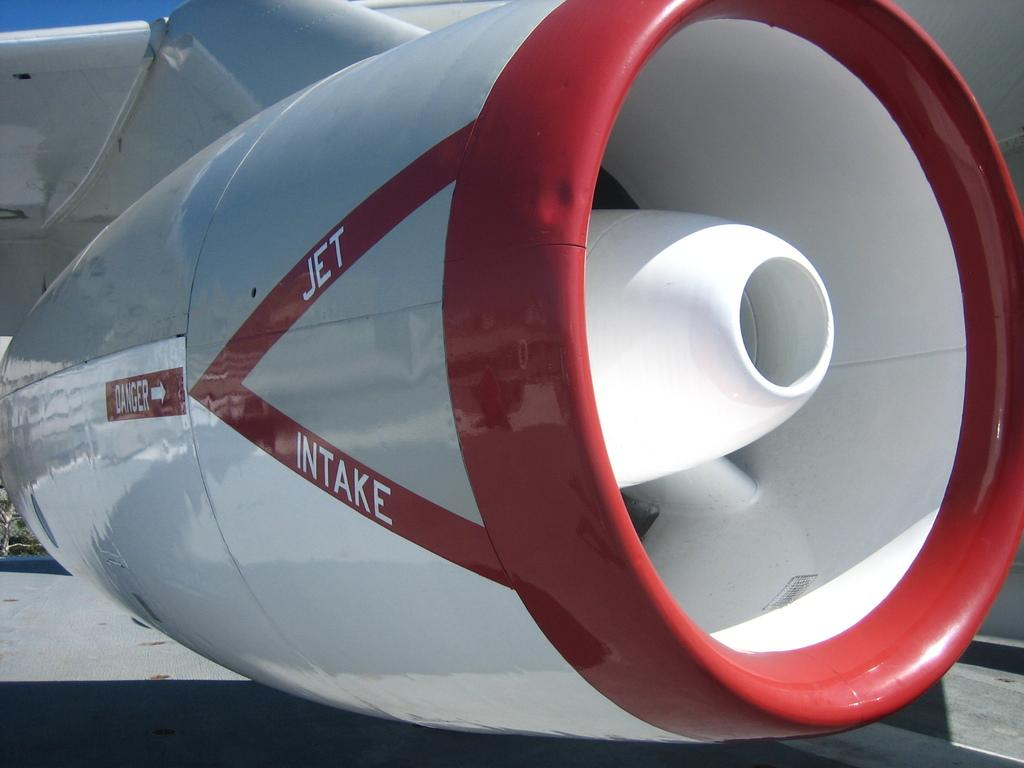<image>
Describe the image concisely. A close up view of a an airplane shows the words Jet Intake in white letters. 